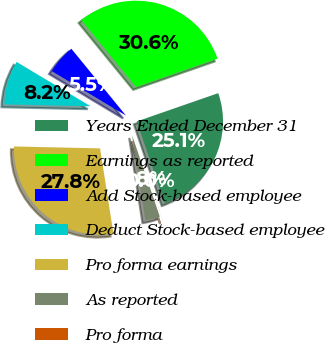<chart> <loc_0><loc_0><loc_500><loc_500><pie_chart><fcel>Years Ended December 31<fcel>Earnings as reported<fcel>Add Stock-based employee<fcel>Deduct Stock-based employee<fcel>Pro forma earnings<fcel>As reported<fcel>Pro forma<nl><fcel>25.09%<fcel>30.58%<fcel>5.5%<fcel>8.24%<fcel>27.83%<fcel>2.75%<fcel>0.01%<nl></chart> 